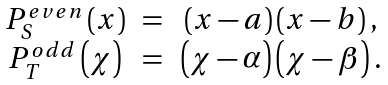<formula> <loc_0><loc_0><loc_500><loc_500>\begin{array} { c c c } P _ { S } ^ { e v e n } \left ( x \right ) & = & \left ( x - a \right ) \left ( x - b \right ) , \\ P _ { T } ^ { o d d } \left ( \chi \right ) & = & \left ( \chi - \alpha \right ) \left ( \chi - \beta \right ) . \end{array}</formula> 